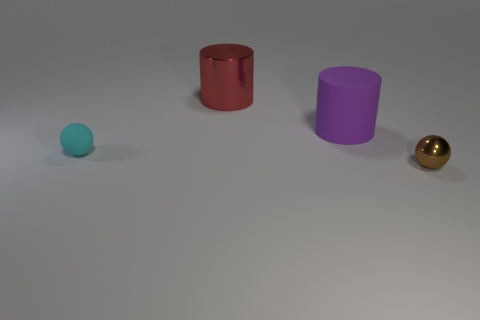How many other tiny brown things are the same shape as the brown thing?
Your answer should be compact. 0. Do the ball behind the tiny brown ball and the big metallic object have the same color?
Ensure brevity in your answer.  No. There is a tiny thing that is behind the small metallic sphere that is to the right of the sphere behind the brown ball; what shape is it?
Your response must be concise. Sphere. Is the size of the brown ball the same as the matte thing that is to the right of the tiny cyan rubber object?
Provide a short and direct response. No. Are there any brown shiny objects of the same size as the rubber ball?
Make the answer very short. Yes. There is a object that is right of the red shiny cylinder and behind the metallic ball; what color is it?
Offer a terse response. Purple. Is the small ball on the right side of the tiny cyan thing made of the same material as the thing left of the big metal cylinder?
Your answer should be compact. No. Does the sphere to the left of the red cylinder have the same size as the purple rubber cylinder?
Keep it short and to the point. No. What shape is the large red metal thing?
Keep it short and to the point. Cylinder. Do the metallic ball and the large shiny thing have the same color?
Provide a short and direct response. No. 